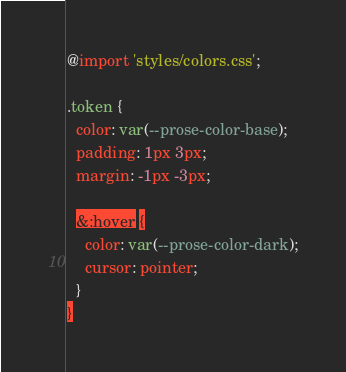Convert code to text. <code><loc_0><loc_0><loc_500><loc_500><_CSS_>@import 'styles/colors.css';

.token {
  color: var(--prose-color-base);
  padding: 1px 3px;
  margin: -1px -3px;

  &:hover {
    color: var(--prose-color-dark);
    cursor: pointer;
  }
}
</code> 